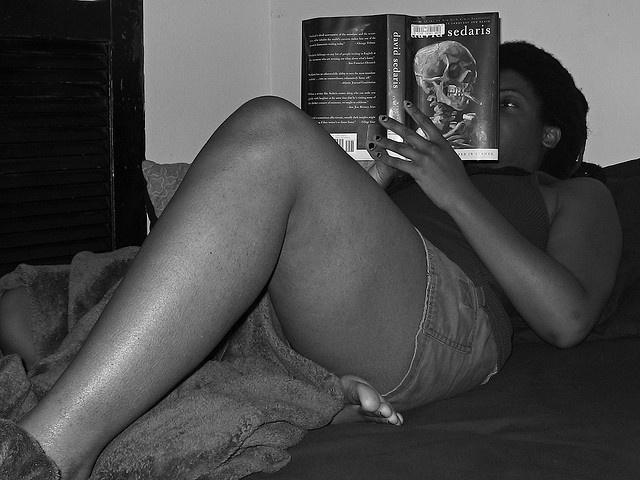Describe the objects in this image and their specific colors. I can see people in black, gray, and lightgray tones, bed in black, darkgray, gray, and lightgray tones, and book in black, gray, darkgray, and lightgray tones in this image. 